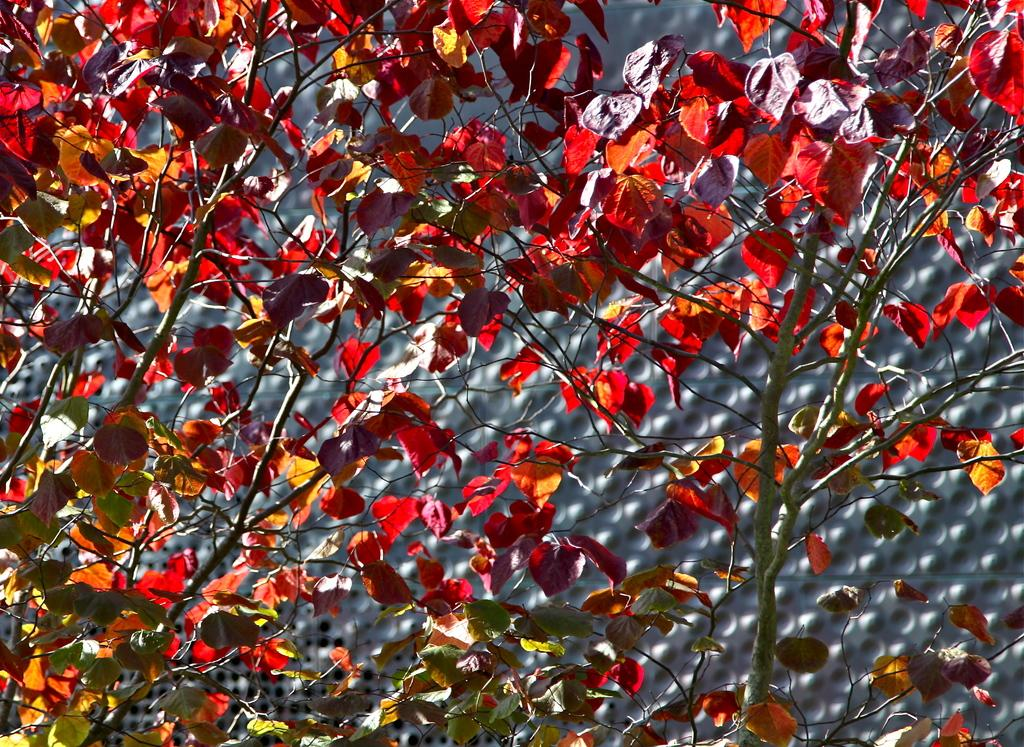What is in the foreground of the image? There are leaves in the foreground of the image. What type of plant do the leaves belong to? The leaves belong to trees. What can be seen in the background of the image? In the background, there appears to be a mesh or a similar pattern. How many rabbits can be seen hopping among the leaves in the image? There are no rabbits present in the image; it only features leaves and a background pattern. What color is the bee buzzing around the leaves in the image? There is no bee present in the image; it only features leaves and a background pattern. 